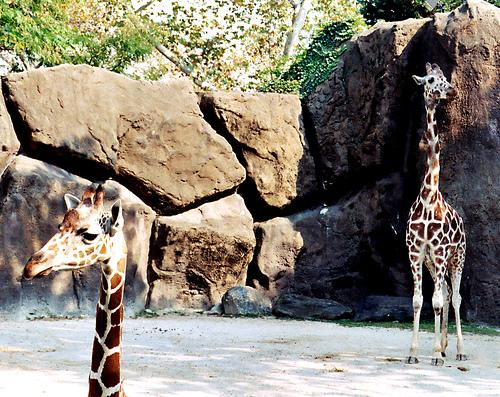Can you identify any specific body parts of the giraffe(s) that are emphasized in the image? The giraffe's head, neck, ears, snout, and feet are emphasized in the image. Describe the ground within the image. The ground is sandy and covers the lower part of the image. Briefly describe the surrounding environment of the giraffes in this image. The giraffes are in an enclosure with sandy ground, trees behind them, and a large rock wall nearby. Assess the overall content and sentiment of the image. The image portrays a peaceful scene of two giraffes in their enclosure. Point out the important features or details mentioned about the giraffe's neck. The giraffe has a tall brown and white neck, and a long neck. What type of natural structure appears in the image, and what is its color? A big brown stone is present in the image. Could you count the number of giraffes in this picture? There are two giraffes in the image. What feature of the giraffe's head is mentioned in the image information? The giraffe has two small horns. What is the primary animal featured in this image? Also, specify its predominant colors. The primary animal is a tall brown and white giraffe. Elaborate on the position of the trees in relation to the giraffe enclosure. The trees are located behind the giraffe enclosure. How would you describe the ears of the giraffe in the image? The giraffe's ears are standing upright Rewrite the following sentence in a descriptive manner: "The giraffe is brown and white." The giraffe exhibits a striking combination of brown and white hues. Observe the giraffe's feet and describe their positions in relation to each other. The giraffe's feet are positioned close together, bearing some similarity to a linear arrangement Are there any other objects specified in the image apart from the giraffes? Yes, a large rock wall, big brown stones, and trees How would you describe the size of the stones in the image? The stones are big and brown Recognize and describe the terrain visible at the bottom of the image. The ground is sandy What does the large object in the image resemble? a tall brown and white giraffe Is the giraffe's neck long or short? The giraffe's neck is long Can you identify any natural formations in the image? Yes, there is a large rock wall and a big brown stone Describe the overall image, highlighting the various objects and their relationships with each other. The image features a tall brown and white giraffe with a long neck, small horns, and upright ears, standing on sandy ground. There are two giraffes in total, positioned within an enclosure surrounded by trees. A large rock wall and big brown stones contribute to the natural setting. What color is the giraffe? The giraffe is brown and white Describe the background scene of the image. There are trees behind the giraffe enclosure Which animal has two small horns in the image? giraffe Count the number of giraffes visible in the image There are two giraffes Can you infer the possible size of the giraffe just by looking at its neck? The giraffe is likely tall because it has a long neck What can be observed in the background of the image? There is a giraffe enclosure with trees behind it Please give a vivid description of the giraffe's snout in the image. The giraffe's snout appears elongated and well-defined 